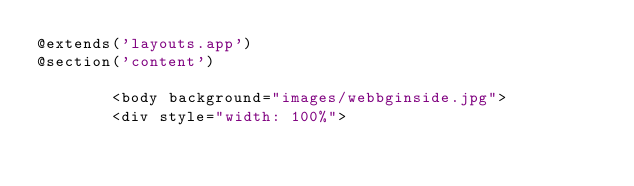Convert code to text. <code><loc_0><loc_0><loc_500><loc_500><_PHP_>@extends('layouts.app')
@section('content')

        <body background="images/webbginside.jpg">
        <div style="width: 100%">
</code> 